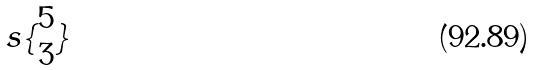<formula> <loc_0><loc_0><loc_500><loc_500>s \{ \begin{matrix} 5 \\ 3 \end{matrix} \}</formula> 